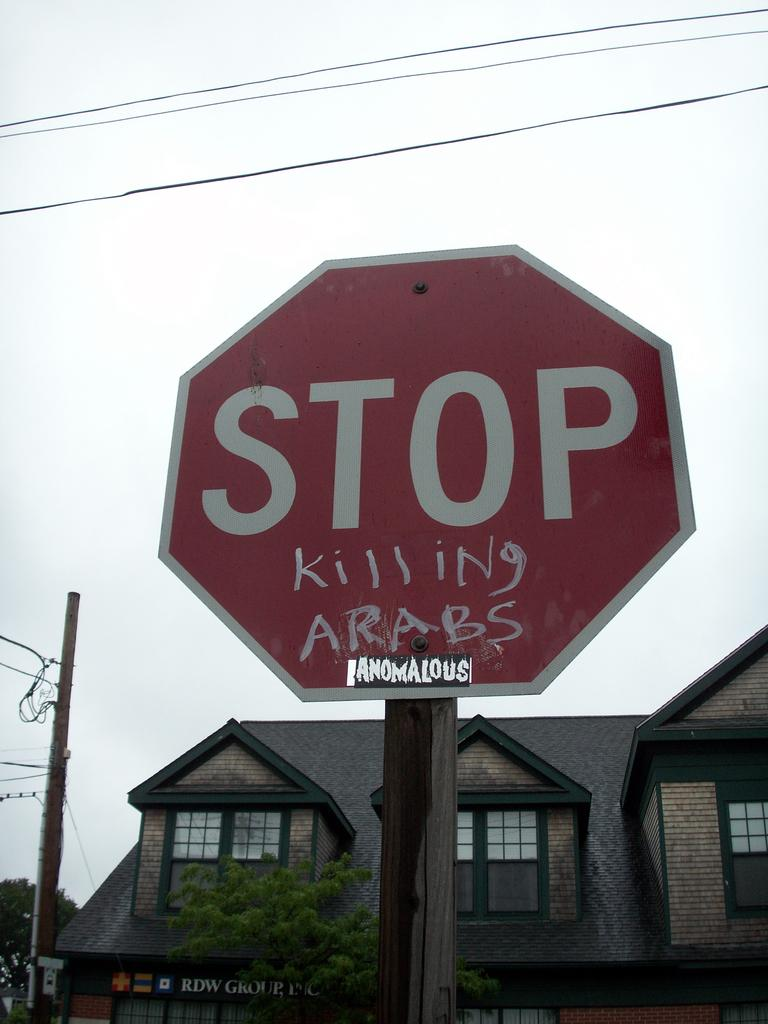Provide a one-sentence caption for the provided image. The Stop signed had graffiti on it saying, "killing Arabs.". 